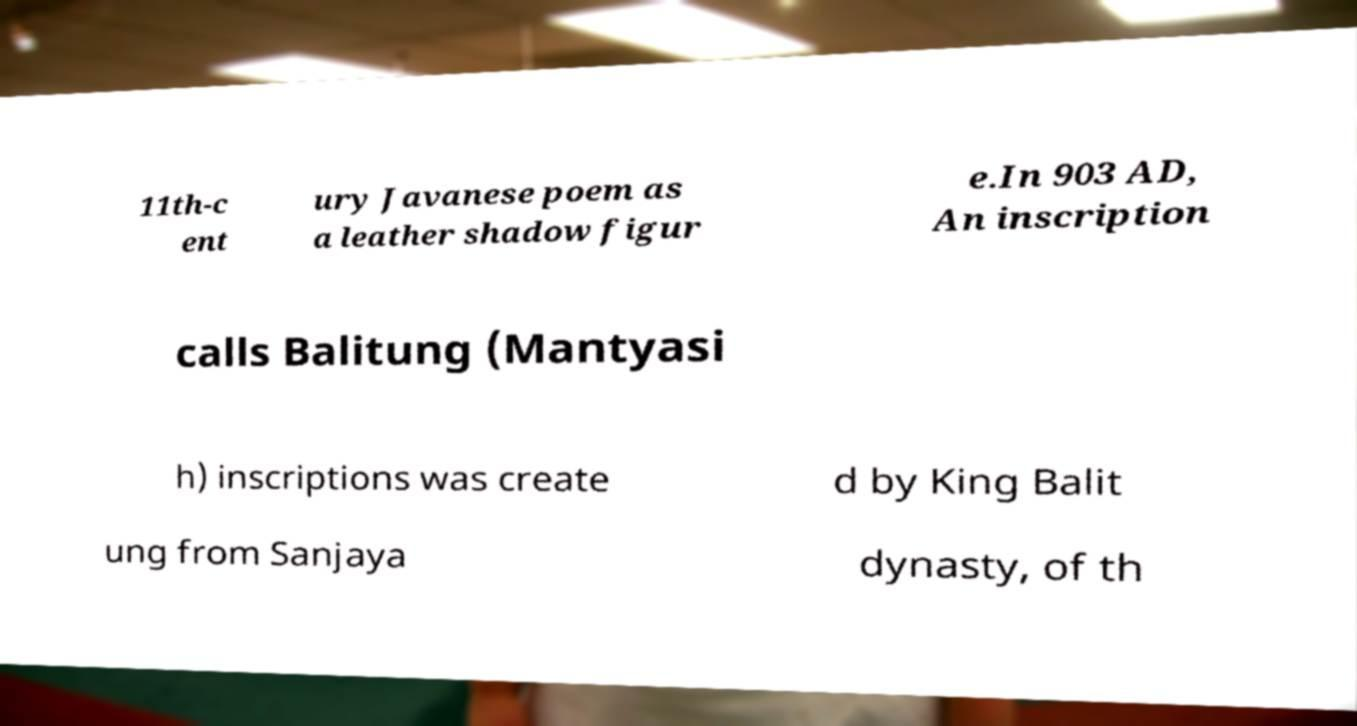There's text embedded in this image that I need extracted. Can you transcribe it verbatim? 11th-c ent ury Javanese poem as a leather shadow figur e.In 903 AD, An inscription calls Balitung (Mantyasi h) inscriptions was create d by King Balit ung from Sanjaya dynasty, of th 